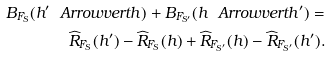Convert formula to latex. <formula><loc_0><loc_0><loc_500><loc_500>B _ { F _ { S } } ( h ^ { \prime } \ A r r o w v e r t h ) + B _ { F _ { S ^ { \prime } } } ( h \ A r r o w v e r t h ^ { \prime } ) = \\ \widehat { R } _ { F _ { S } } ( h ^ { \prime } ) - \widehat { R } _ { F _ { S } } ( h ) + \widehat { R } _ { F _ { S ^ { \prime } } } ( h ) - \widehat { R } _ { F _ { S ^ { \prime } } } ( h ^ { \prime } ) .</formula> 